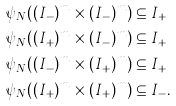Convert formula to latex. <formula><loc_0><loc_0><loc_500><loc_500>\psi _ { N } ( ( I _ { - } ) ^ { m } \times ( I _ { - } ) ^ { m } ) & \subseteq I _ { + } \\ \psi _ { N } ( ( I _ { + } ) ^ { m } \times ( I _ { - } ) ^ { m } ) & \subseteq I _ { + } \\ \psi _ { N } ( ( I _ { - } ) ^ { m } \times ( I _ { + } ) ^ { m } ) & \subseteq I _ { + } \\ \psi _ { N } ( ( I _ { + } ) ^ { m } \times ( I _ { + } ) ^ { m } ) & \subseteq I _ { - } .</formula> 